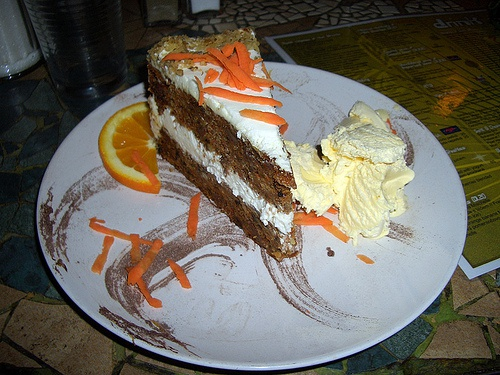Describe the objects in this image and their specific colors. I can see dining table in black, darkgray, olive, gray, and lightgray tones, cake in black, maroon, olive, and lightgray tones, book in black, darkgreen, and gray tones, cup in black, purple, and gray tones, and orange in black, brown, and olive tones in this image. 